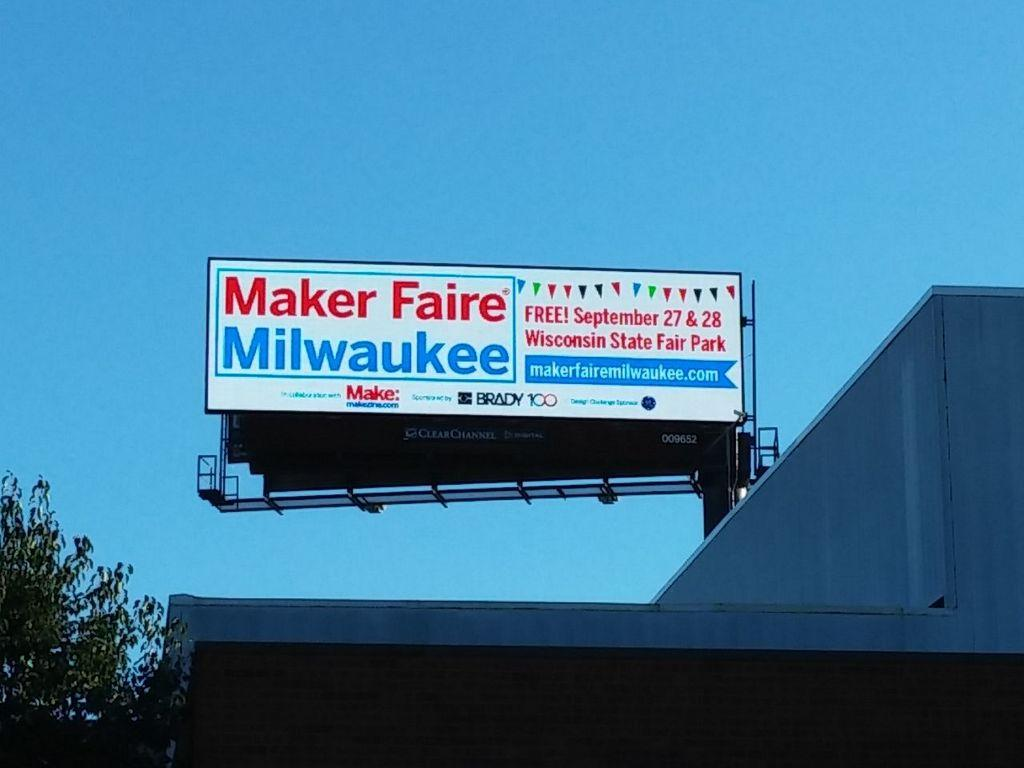<image>
Render a clear and concise summary of the photo. Maker Faire Milwaukee banner on top of a building for the Wisconsin State Fair Park. 